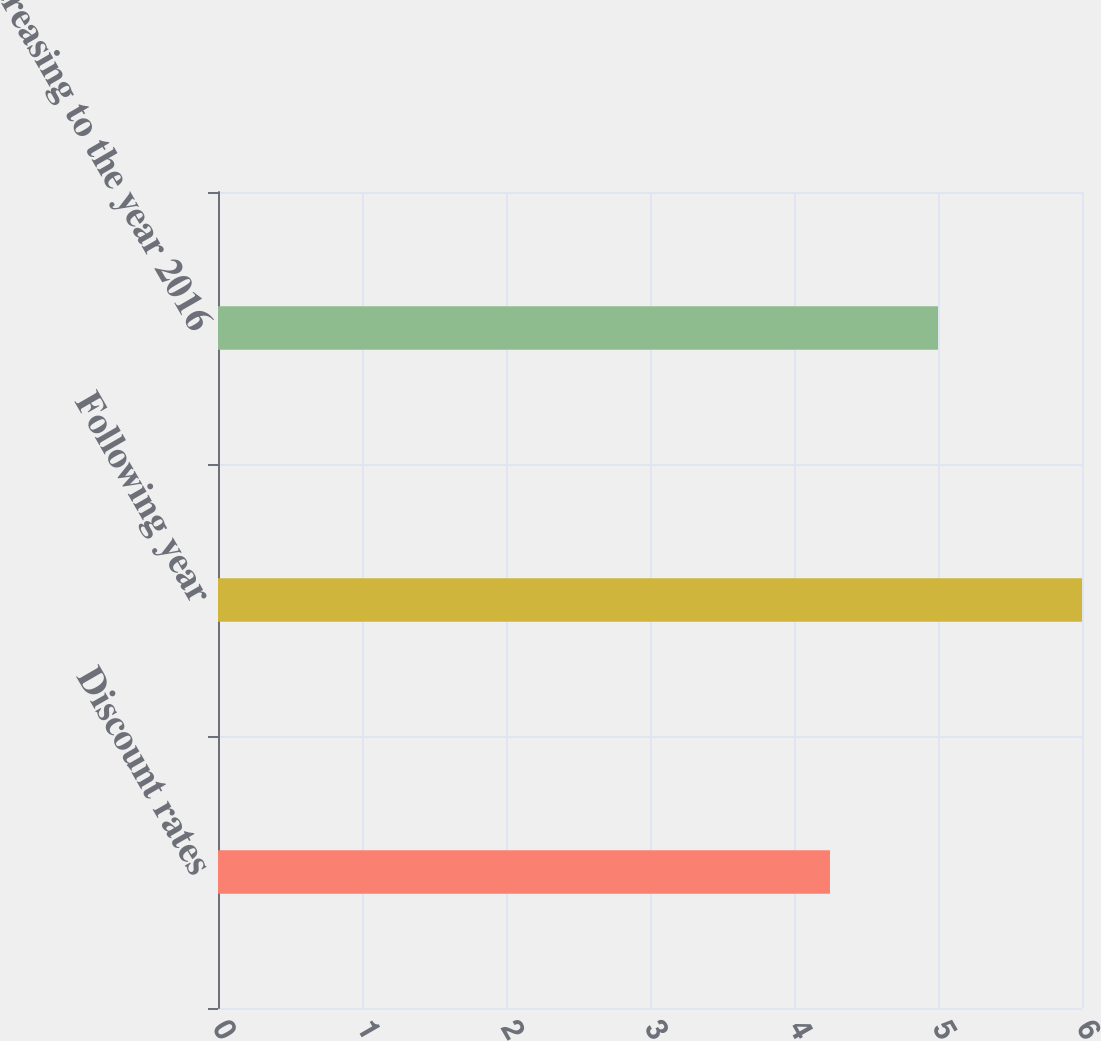<chart> <loc_0><loc_0><loc_500><loc_500><bar_chart><fcel>Discount rates<fcel>Following year<fcel>Decreasing to the year 2016<nl><fcel>4.25<fcel>6<fcel>5<nl></chart> 